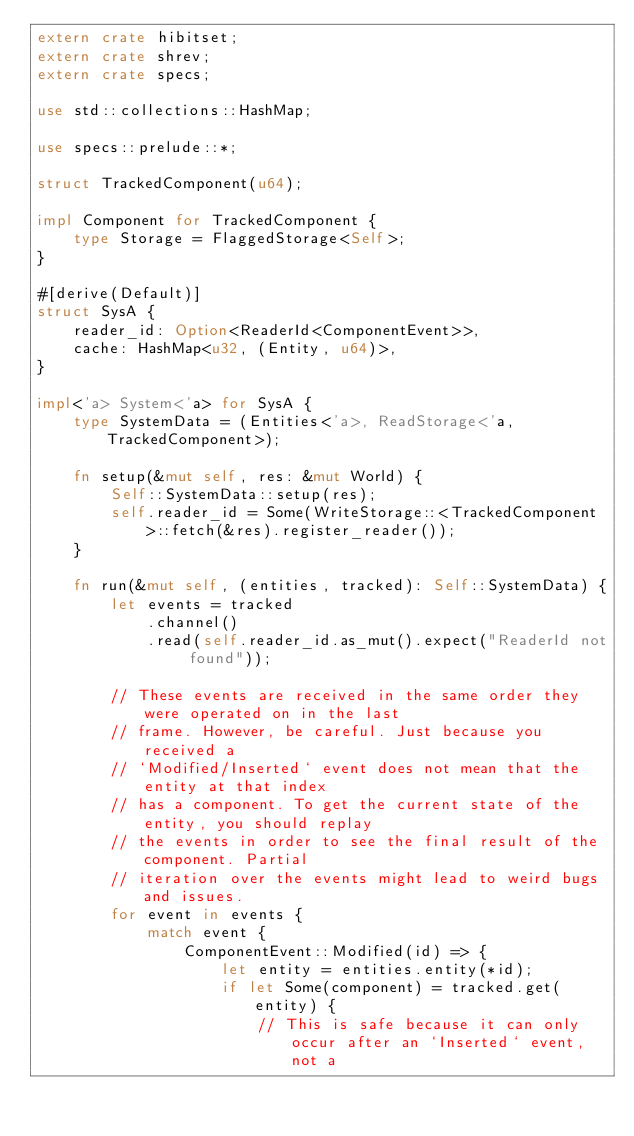<code> <loc_0><loc_0><loc_500><loc_500><_Rust_>extern crate hibitset;
extern crate shrev;
extern crate specs;

use std::collections::HashMap;

use specs::prelude::*;

struct TrackedComponent(u64);

impl Component for TrackedComponent {
    type Storage = FlaggedStorage<Self>;
}

#[derive(Default)]
struct SysA {
    reader_id: Option<ReaderId<ComponentEvent>>,
    cache: HashMap<u32, (Entity, u64)>,
}

impl<'a> System<'a> for SysA {
    type SystemData = (Entities<'a>, ReadStorage<'a, TrackedComponent>);

    fn setup(&mut self, res: &mut World) {
        Self::SystemData::setup(res);
        self.reader_id = Some(WriteStorage::<TrackedComponent>::fetch(&res).register_reader());
    }

    fn run(&mut self, (entities, tracked): Self::SystemData) {
        let events = tracked
            .channel()
            .read(self.reader_id.as_mut().expect("ReaderId not found"));

        // These events are received in the same order they were operated on in the last
        // frame. However, be careful. Just because you received a
        // `Modified/Inserted` event does not mean that the entity at that index
        // has a component. To get the current state of the entity, you should replay
        // the events in order to see the final result of the component. Partial
        // iteration over the events might lead to weird bugs and issues.
        for event in events {
            match event {
                ComponentEvent::Modified(id) => {
                    let entity = entities.entity(*id);
                    if let Some(component) = tracked.get(entity) {
                        // This is safe because it can only occur after an `Inserted` event, not a</code> 